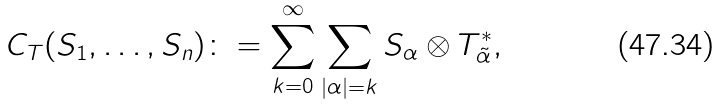<formula> <loc_0><loc_0><loc_500><loc_500>C _ { T } ( S _ { 1 } , \dots , S _ { n } ) \colon = \sum _ { k = 0 } ^ { \infty } \sum _ { | \alpha | = k } S _ { \alpha } \otimes T _ { \tilde { \alpha } } ^ { * } ,</formula> 